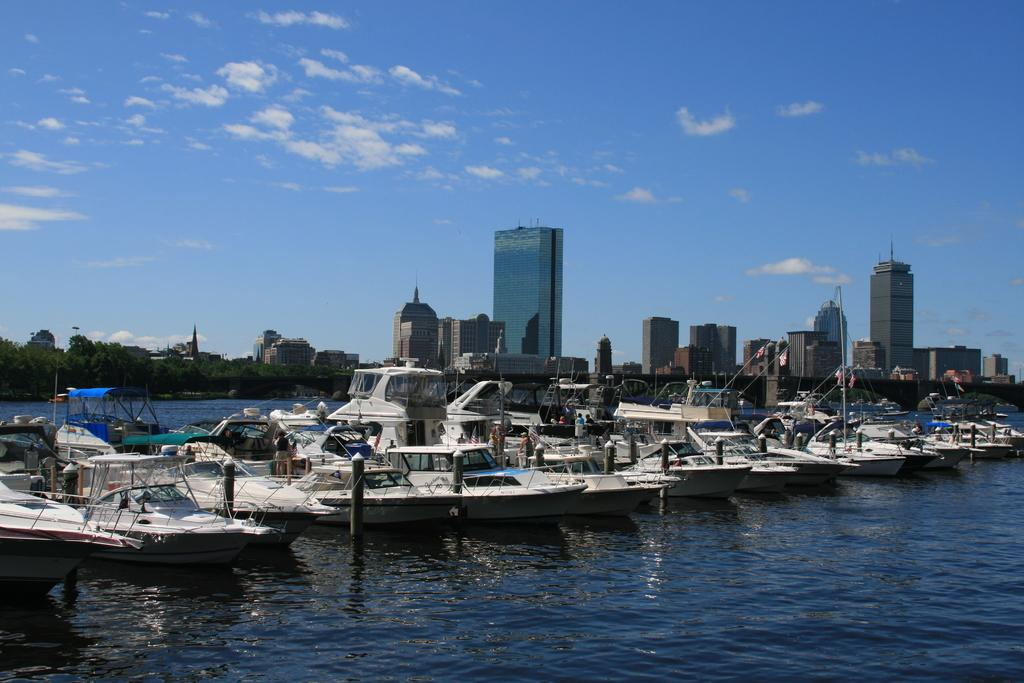What is the primary element in the image? There is water in the image. What else can be seen in the water? There are boats in the image. What structures are visible in the image? There are buildings in the image. What type of vegetation is present in the image? There are trees in the image. What is visible in the background of the image? The sky is visible in the image, and there are clouds present. What type of cheese is being used to build the buildings in the image? There is no cheese present in the image; the buildings are made of traditional construction materials. 